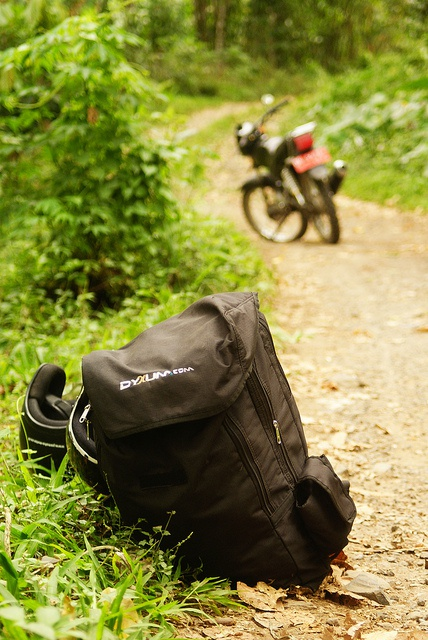Describe the objects in this image and their specific colors. I can see backpack in olive, black, and gray tones and motorcycle in olive, tan, and black tones in this image. 